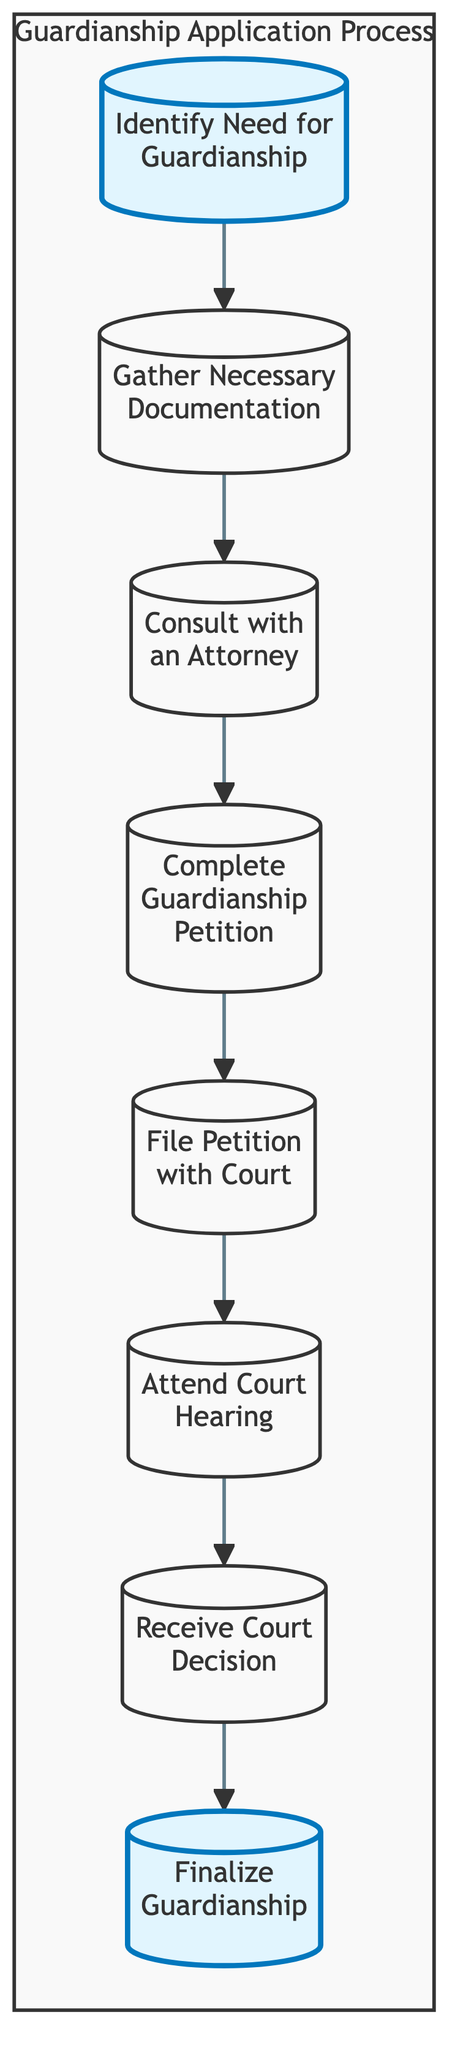What is the first step to apply for guardianship? The first step in the flow chart is "Identify Need for Guardianship," which indicates determining if guardianship is necessary.
Answer: Identify Need for Guardianship How many total steps are there in the guardianship application process? By counting the nodes in the flow chart, there are a total of 8 steps involved in the guardianship application process.
Answer: 8 What step comes immediately after gathering necessary documentation? According to the flow chart, the step that follows "Gather Necessary Documentation" is "Consult with an Attorney."
Answer: Consult with an Attorney What is the last step in the process of obtaining guardianship? The final step as indicated in the flow chart is "Finalize Guardianship," which involves completing additional paperwork if granted.
Answer: Finalize Guardianship Which step is required to formally file for guardianship? The step required for formally filing is "File Petition with Court," as it involves submitting the completed petition and necessary documentation.
Answer: File Petition with Court What must happen before attending the court hearing? Prior to attending the court hearing, you must have "Filed Petition with Court," as this step is essential for presenting your case to the judge.
Answer: Filed Petition with Court What is required to complete the guardianship petition? To complete the guardianship petition, the necessary action is to "Fill out the legal forms required to file for guardianship."
Answer: Fill out the legal forms required to file for guardianship Which two steps directly link to the first step? The "Gather Necessary Documentation" and "Consult with an Attorney" steps are both directly linked to "Identify Need for Guardianship."
Answer: Gather Necessary Documentation, Consult with an Attorney 